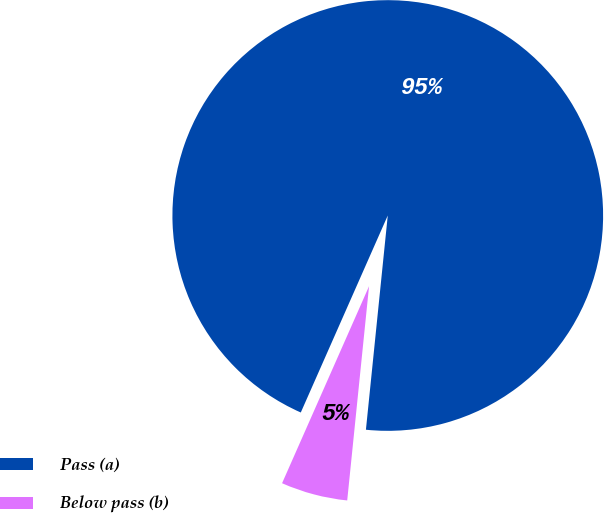Convert chart to OTSL. <chart><loc_0><loc_0><loc_500><loc_500><pie_chart><fcel>Pass (a)<fcel>Below pass (b)<nl><fcel>95.0%<fcel>5.0%<nl></chart> 